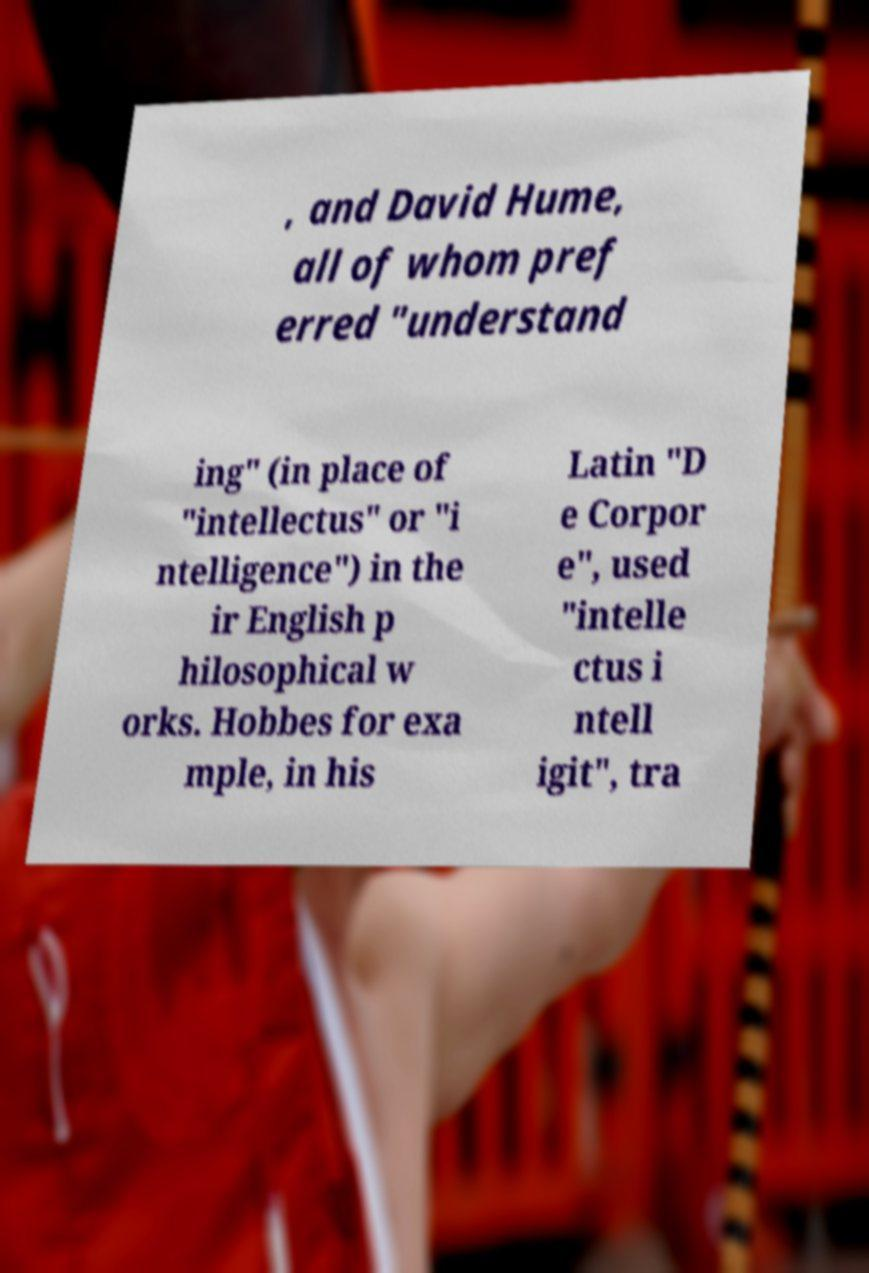Please identify and transcribe the text found in this image. , and David Hume, all of whom pref erred "understand ing" (in place of "intellectus" or "i ntelligence") in the ir English p hilosophical w orks. Hobbes for exa mple, in his Latin "D e Corpor e", used "intelle ctus i ntell igit", tra 